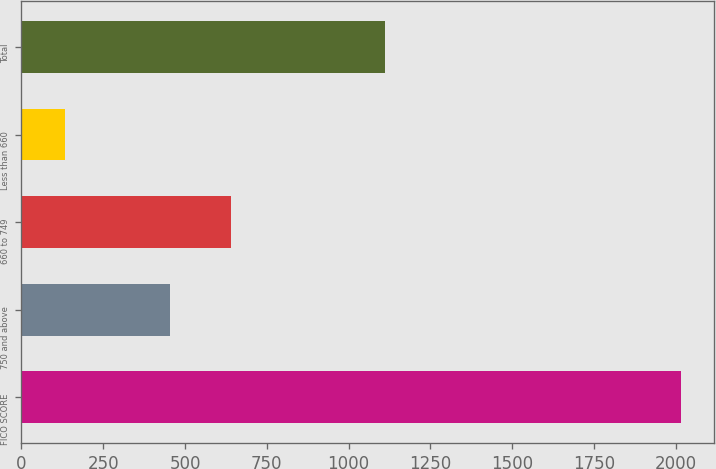<chart> <loc_0><loc_0><loc_500><loc_500><bar_chart><fcel>FICO SCORE<fcel>750 and above<fcel>660 to 749<fcel>Less than 660<fcel>Total<nl><fcel>2016<fcel>453<fcel>641.4<fcel>132<fcel>1111<nl></chart> 